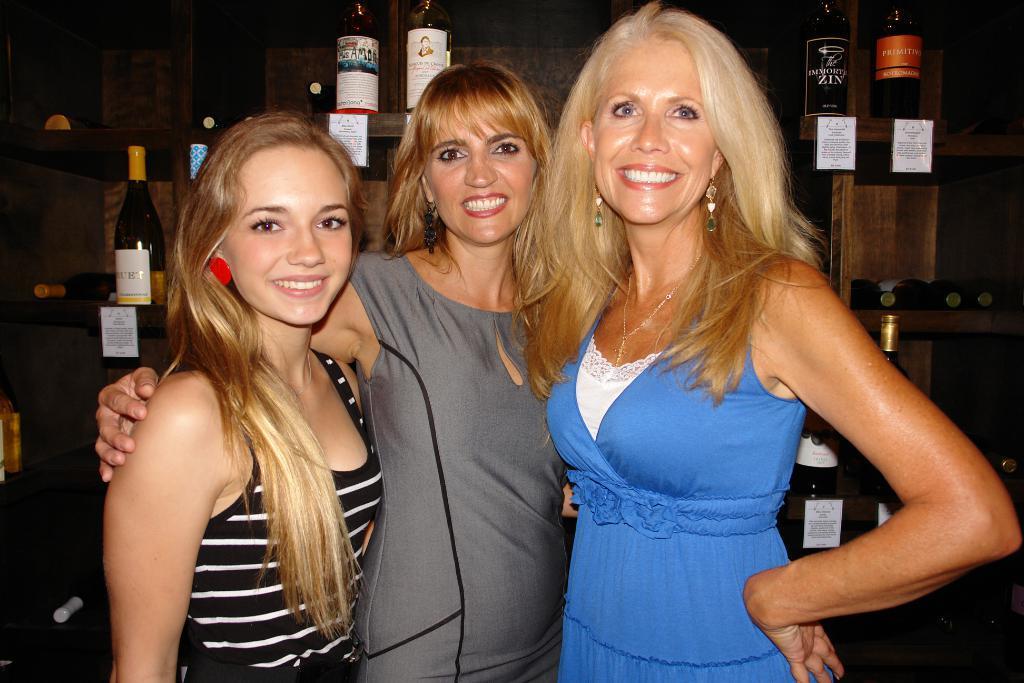How would you summarize this image in a sentence or two? In this image there are three girls one beside the other. In the background there are wine bottles which are kept on the wooden shelves. 